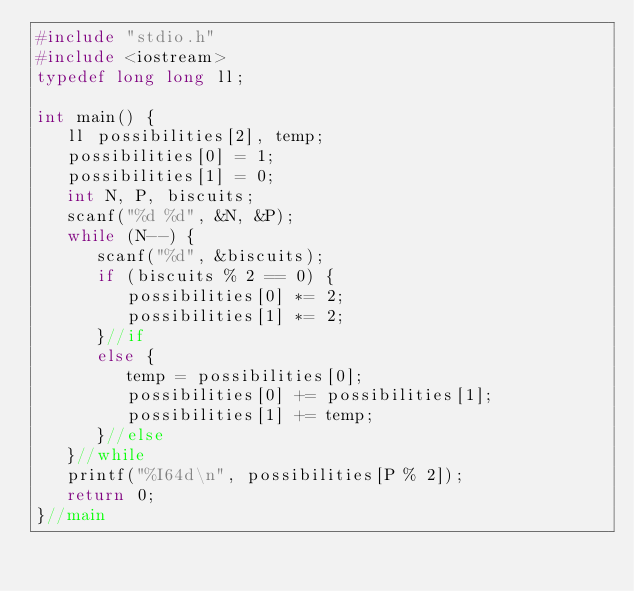<code> <loc_0><loc_0><loc_500><loc_500><_C++_>#include "stdio.h"
#include <iostream>
typedef long long ll;

int main() {
   ll possibilities[2], temp;
   possibilities[0] = 1;
   possibilities[1] = 0;
   int N, P, biscuits;
   scanf("%d %d", &N, &P);
   while (N--) {
      scanf("%d", &biscuits);
      if (biscuits % 2 == 0) {
         possibilities[0] *= 2;
         possibilities[1] *= 2;
      }//if
      else {
         temp = possibilities[0];
         possibilities[0] += possibilities[1];
         possibilities[1] += temp;
      }//else
   }//while
   printf("%I64d\n", possibilities[P % 2]);
   return 0;
}//main
</code> 